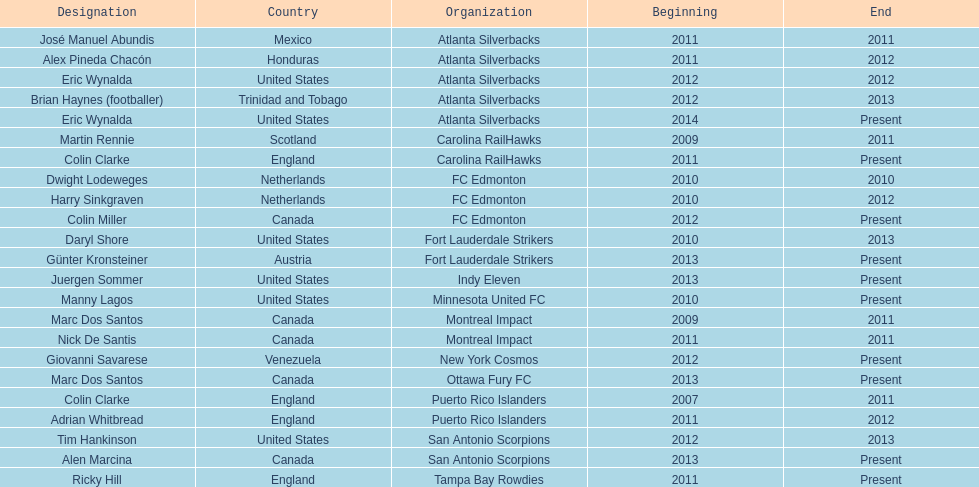Who is the last to coach the san antonio scorpions? Alen Marcina. 